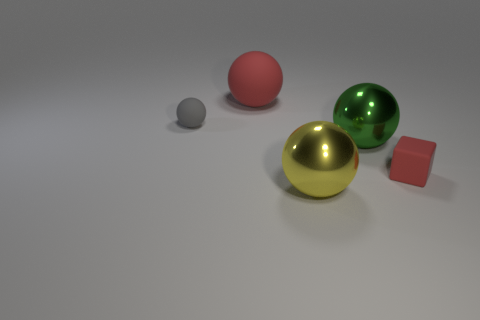The gray rubber thing that is the same shape as the green shiny object is what size?
Your answer should be compact. Small. What is the shape of the small red matte object?
Your answer should be very brief. Cube. What size is the other object that is the same color as the big rubber object?
Provide a succinct answer. Small. Is there a block made of the same material as the red ball?
Make the answer very short. Yes. Are there more large matte cylinders than tiny gray matte objects?
Offer a terse response. No. Are the tiny gray object and the big yellow ball made of the same material?
Offer a very short reply. No. How many matte things are either small gray things or red cylinders?
Offer a very short reply. 1. There is a metallic ball that is the same size as the yellow metal thing; what color is it?
Give a very brief answer. Green. What number of other tiny matte objects are the same shape as the green object?
Offer a very short reply. 1. What number of cylinders are large metal objects or tiny red rubber objects?
Your response must be concise. 0. 